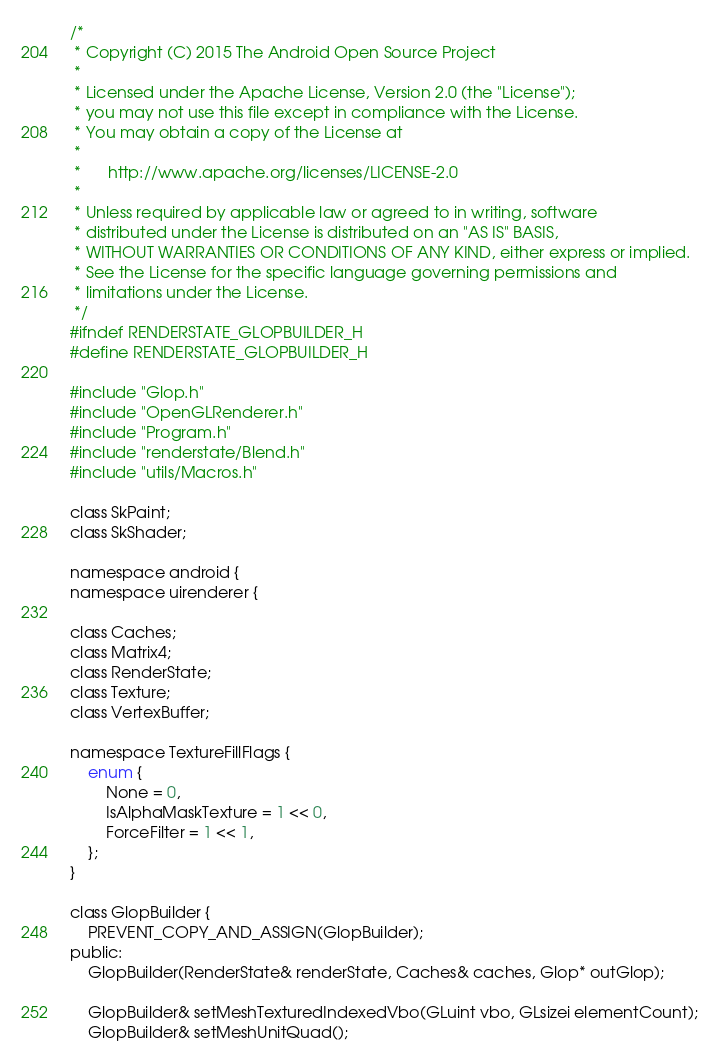Convert code to text. <code><loc_0><loc_0><loc_500><loc_500><_C_>/*
 * Copyright (C) 2015 The Android Open Source Project
 *
 * Licensed under the Apache License, Version 2.0 (the "License");
 * you may not use this file except in compliance with the License.
 * You may obtain a copy of the License at
 *
 *      http://www.apache.org/licenses/LICENSE-2.0
 *
 * Unless required by applicable law or agreed to in writing, software
 * distributed under the License is distributed on an "AS IS" BASIS,
 * WITHOUT WARRANTIES OR CONDITIONS OF ANY KIND, either express or implied.
 * See the License for the specific language governing permissions and
 * limitations under the License.
 */
#ifndef RENDERSTATE_GLOPBUILDER_H
#define RENDERSTATE_GLOPBUILDER_H

#include "Glop.h"
#include "OpenGLRenderer.h"
#include "Program.h"
#include "renderstate/Blend.h"
#include "utils/Macros.h"

class SkPaint;
class SkShader;

namespace android {
namespace uirenderer {

class Caches;
class Matrix4;
class RenderState;
class Texture;
class VertexBuffer;

namespace TextureFillFlags {
    enum {
        None = 0,
        IsAlphaMaskTexture = 1 << 0,
        ForceFilter = 1 << 1,
    };
}

class GlopBuilder {
    PREVENT_COPY_AND_ASSIGN(GlopBuilder);
public:
    GlopBuilder(RenderState& renderState, Caches& caches, Glop* outGlop);

    GlopBuilder& setMeshTexturedIndexedVbo(GLuint vbo, GLsizei elementCount);
    GlopBuilder& setMeshUnitQuad();</code> 